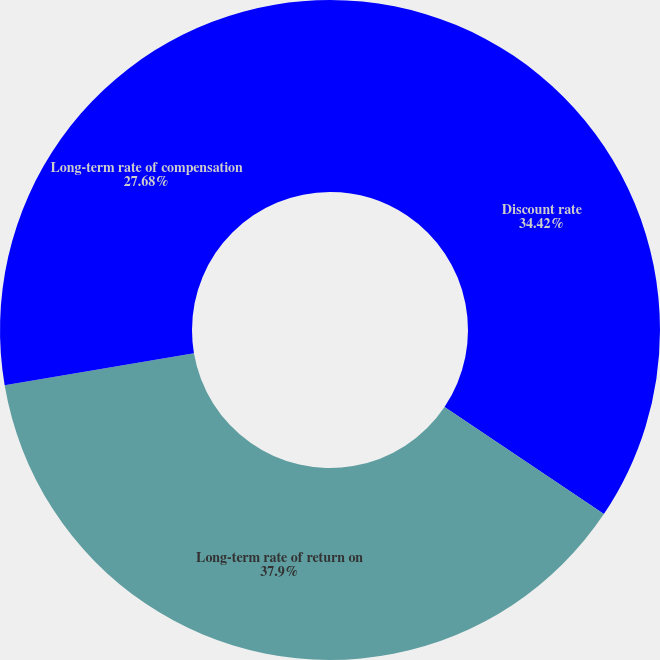Convert chart. <chart><loc_0><loc_0><loc_500><loc_500><pie_chart><fcel>Discount rate<fcel>Long-term rate of return on<fcel>Long-term rate of compensation<nl><fcel>34.42%<fcel>37.9%<fcel>27.68%<nl></chart> 